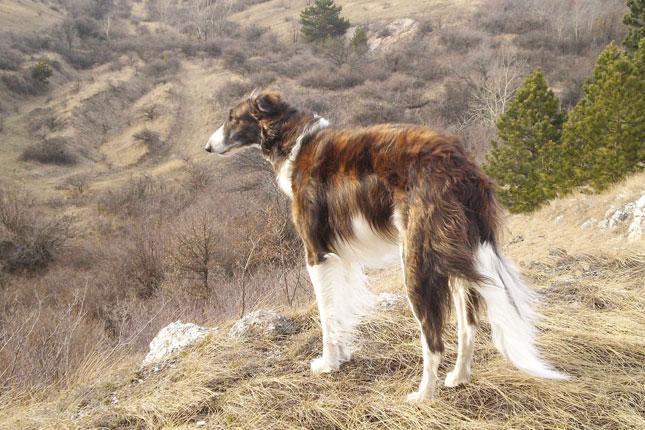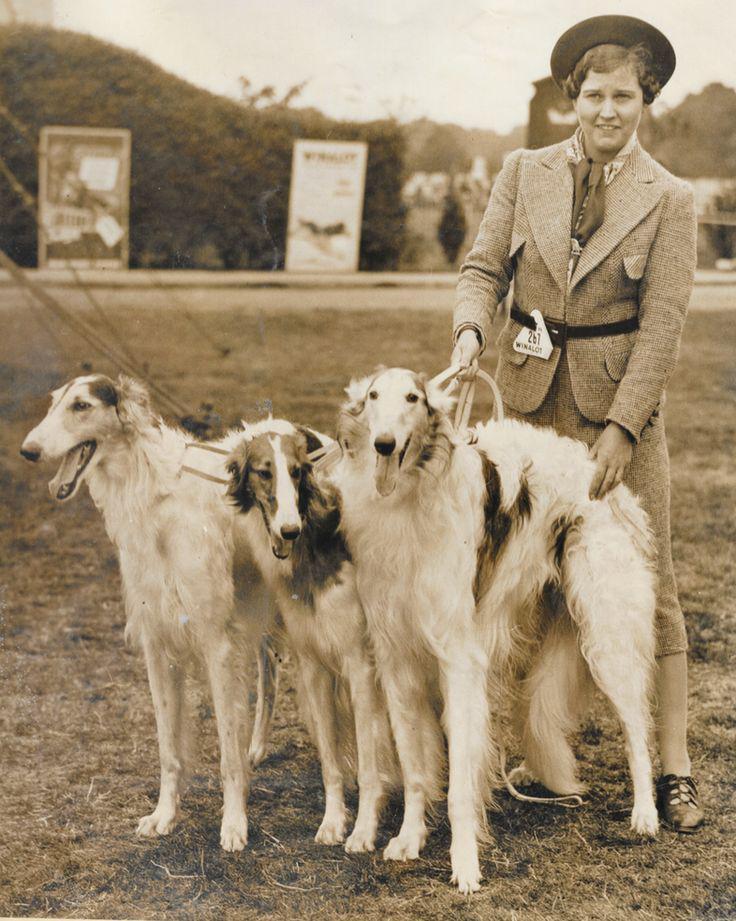The first image is the image on the left, the second image is the image on the right. Given the left and right images, does the statement "The right image shows a woman in a long dress, standing behind an afghan hound, with flowers held in one hand." hold true? Answer yes or no. No. The first image is the image on the left, the second image is the image on the right. For the images displayed, is the sentence "A woman is standing with a single dog in the image on the right." factually correct? Answer yes or no. No. 